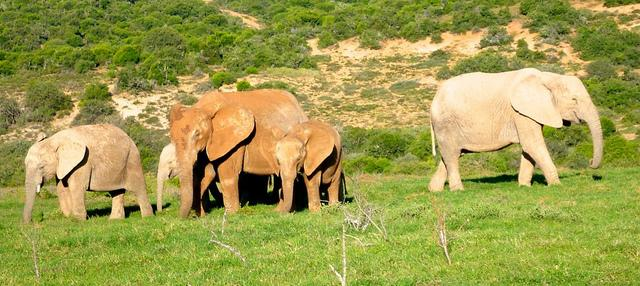What color is the skin of the dirty elephant in the middle? brown 